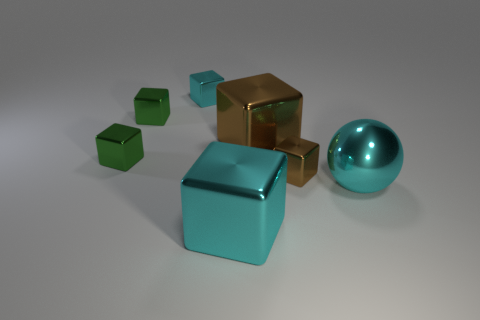What number of metallic things are either big spheres or small green things?
Keep it short and to the point. 3. There is a small metallic thing that is the same color as the big metallic ball; what is its shape?
Give a very brief answer. Cube. What number of green metallic blocks have the same size as the metallic sphere?
Provide a succinct answer. 0. There is a big metallic object that is in front of the small brown block and left of the big shiny sphere; what color is it?
Keep it short and to the point. Cyan. What number of things are either small blue matte cylinders or tiny cyan metal objects?
Your response must be concise. 1. What number of big things are green blocks or blocks?
Make the answer very short. 2. Is there any other thing that is the same color as the big shiny ball?
Your response must be concise. Yes. There is a object that is in front of the tiny brown cube and to the right of the large brown metallic block; what is its size?
Ensure brevity in your answer.  Large. Is the color of the big metal cube behind the ball the same as the small metal thing right of the tiny cyan thing?
Make the answer very short. Yes. What number of other objects are the same material as the small cyan thing?
Provide a succinct answer. 6. 